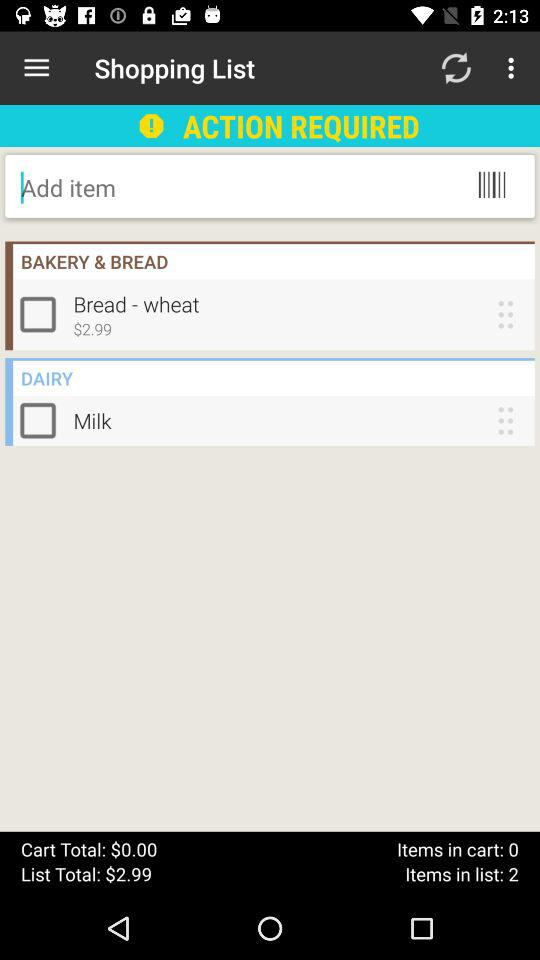What is the price of "Bread - wheat"? The price of "Bread - wheat" is $2.99. 